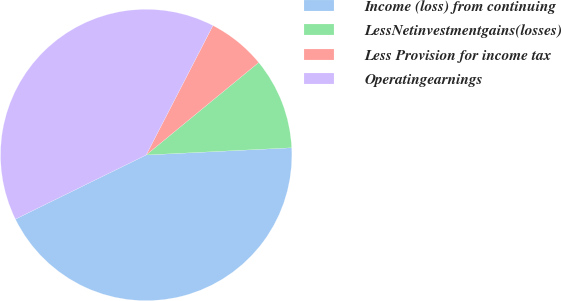Convert chart to OTSL. <chart><loc_0><loc_0><loc_500><loc_500><pie_chart><fcel>Income (loss) from continuing<fcel>LessNetinvestmentgains(losses)<fcel>Less Provision for income tax<fcel>Operatingearnings<nl><fcel>43.53%<fcel>10.16%<fcel>6.47%<fcel>39.84%<nl></chart> 